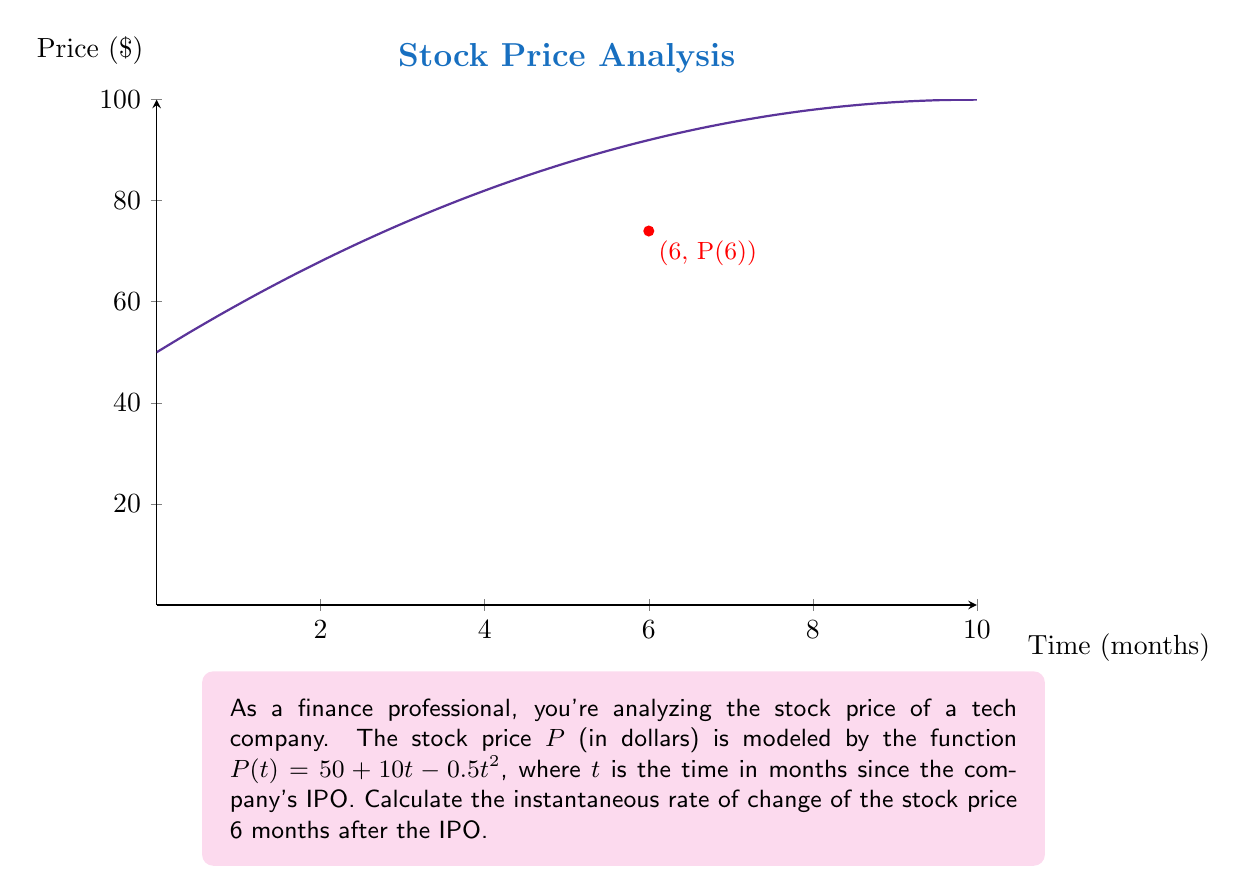Provide a solution to this math problem. To find the instantaneous rate of change, we need to calculate the derivative of $P(t)$ and evaluate it at $t=6$. Let's break this down step-by-step:

1) The given function is $P(t) = 50 + 10t - 0.5t^2$

2) To find the derivative, we apply the power rule and constant rule:
   $$P'(t) = 0 + 10 - 0.5(2t) = 10 - t$$

3) This derivative $P'(t)$ represents the instantaneous rate of change of the stock price at any time $t$.

4) We're asked to find the rate of change at $t=6$, so we substitute this value:
   $$P'(6) = 10 - 6 = 4$$

5) Therefore, 6 months after the IPO, the stock price is changing at a rate of $4 per month.

Note: The positive value indicates the stock price is still increasing at this point, but at a slower rate than initially due to the negative quadratic term in the original function.
Answer: $4 per month 